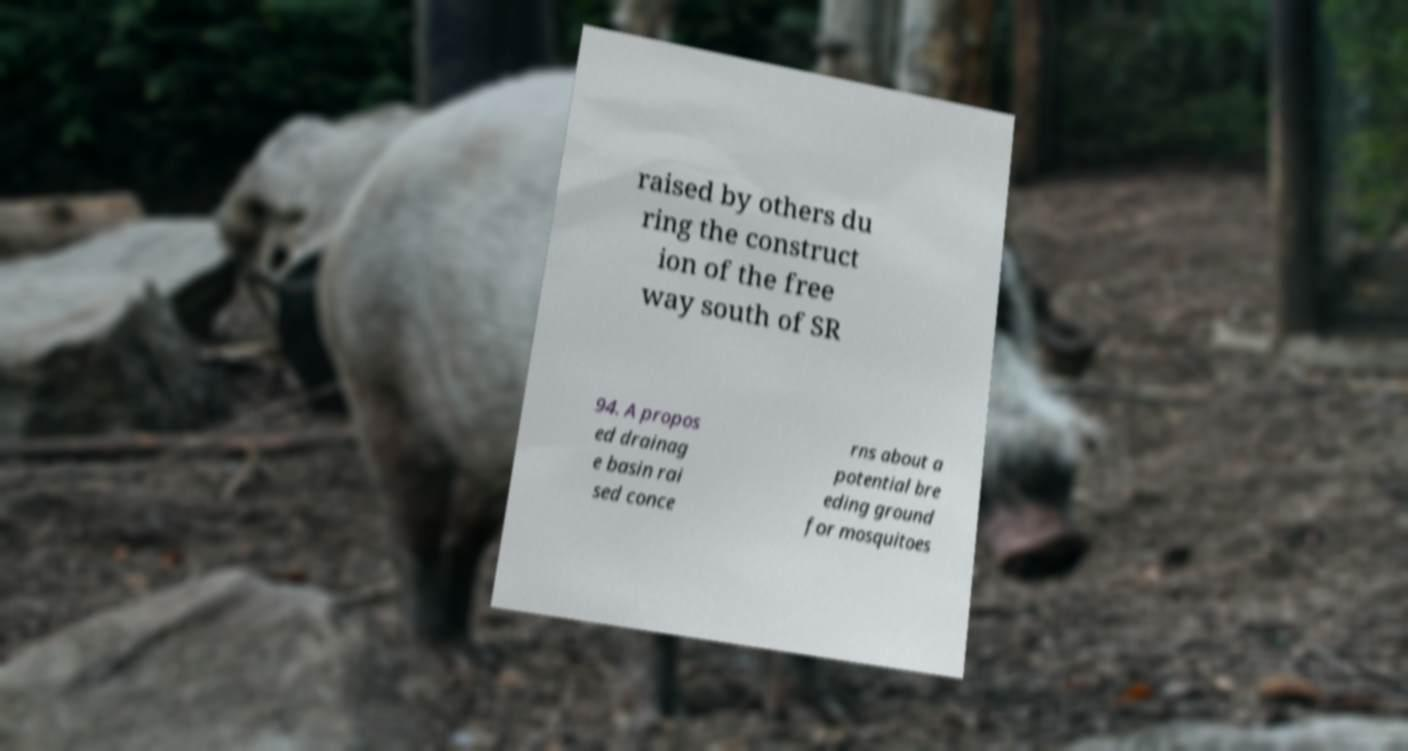Can you accurately transcribe the text from the provided image for me? raised by others du ring the construct ion of the free way south of SR 94. A propos ed drainag e basin rai sed conce rns about a potential bre eding ground for mosquitoes 